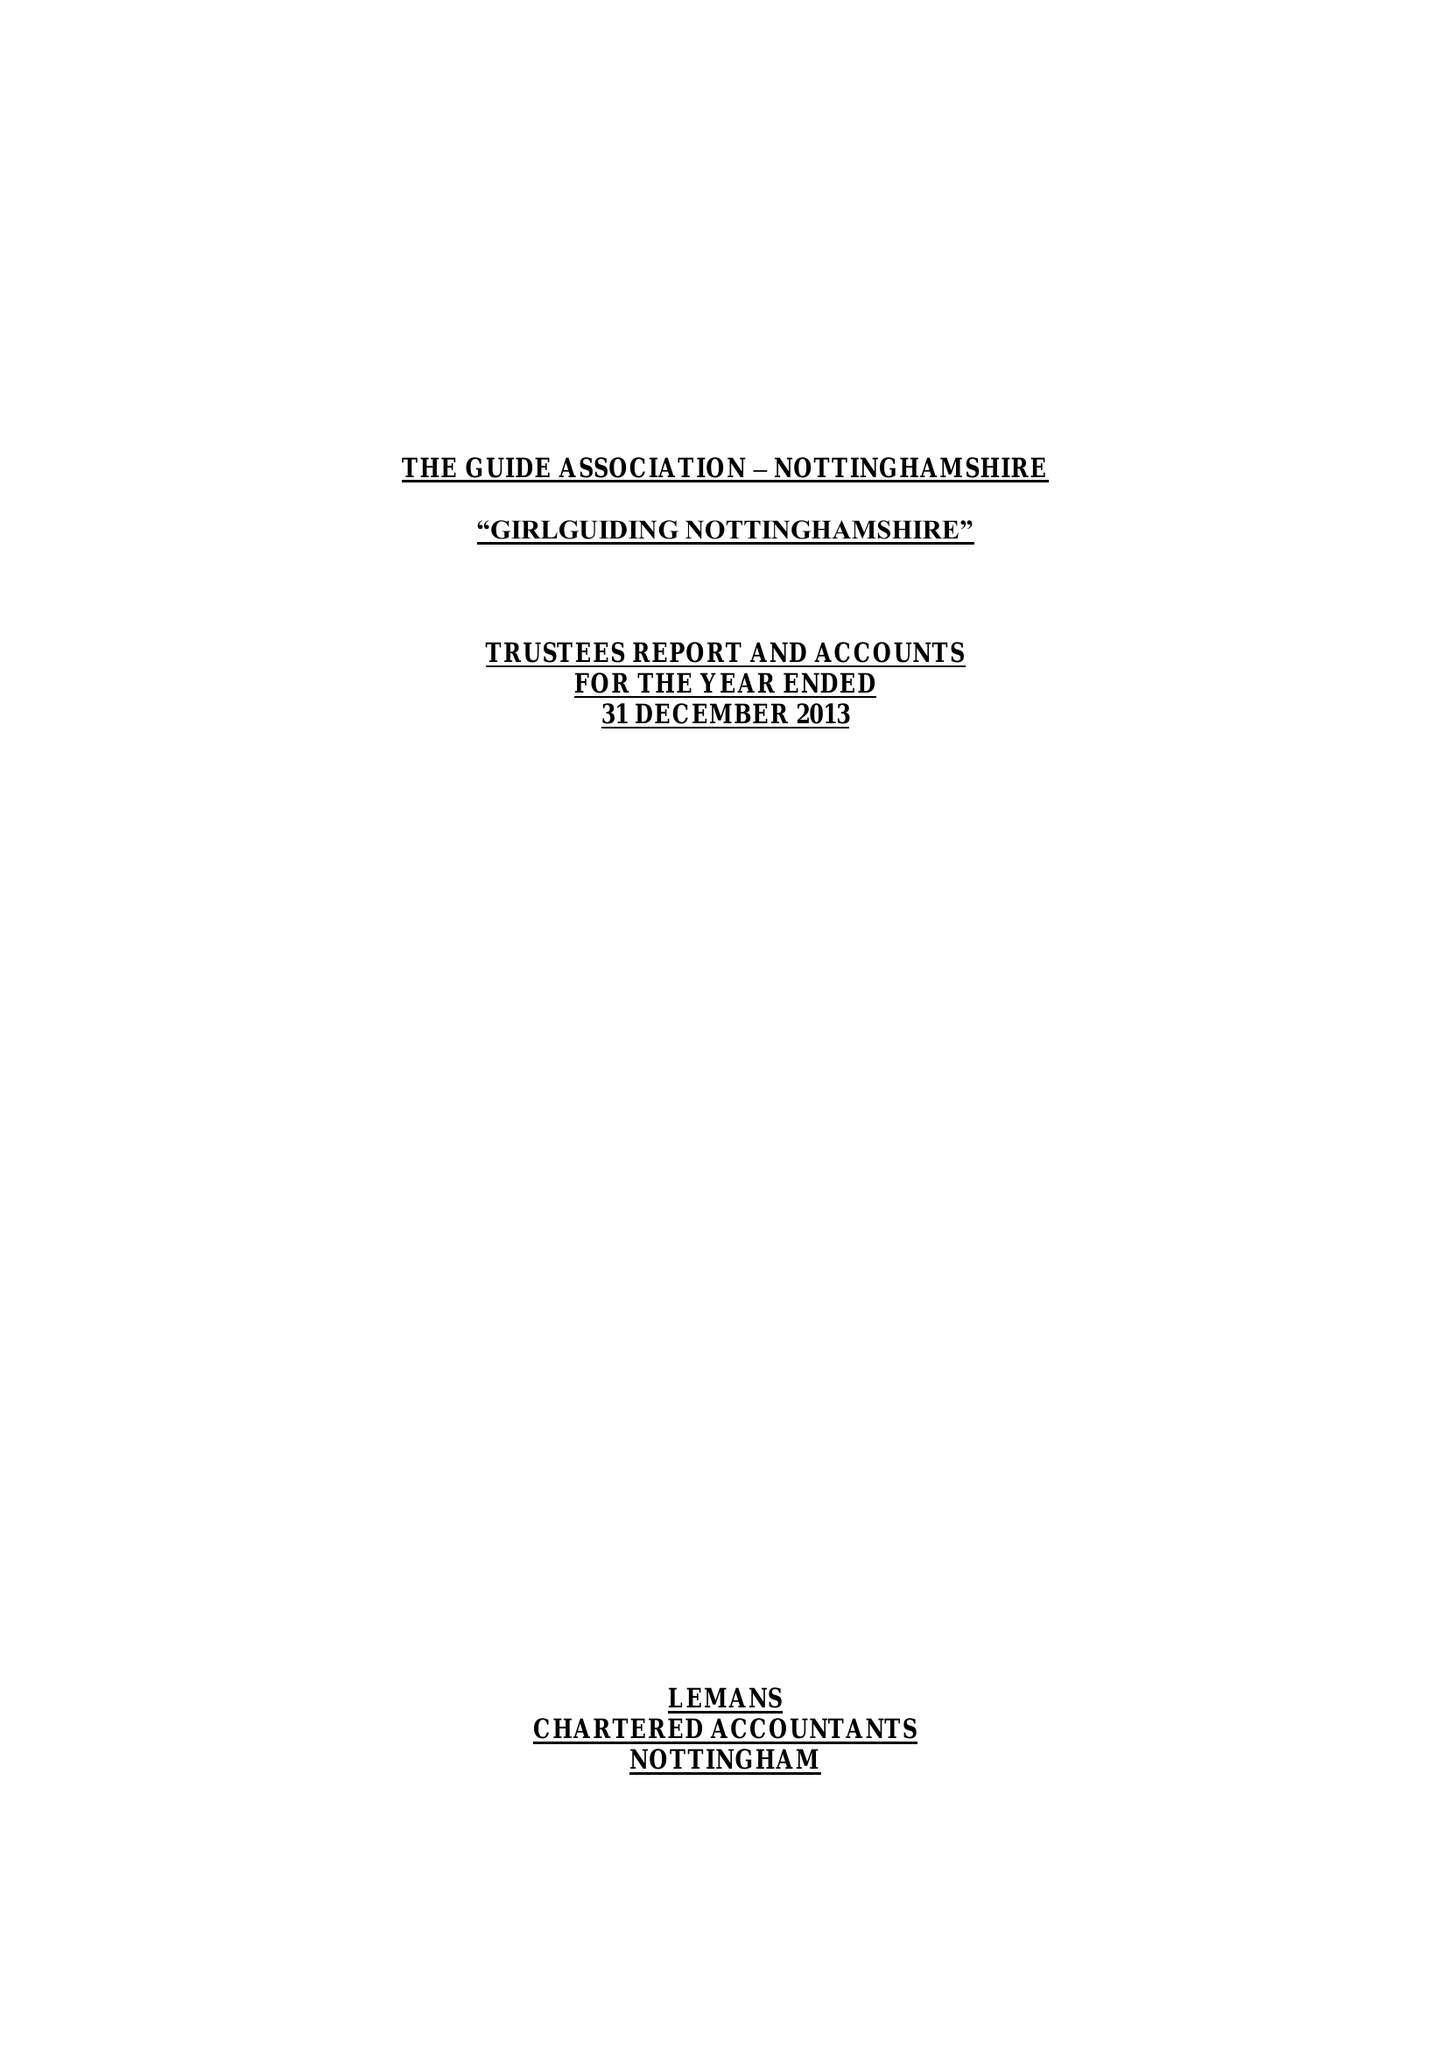What is the value for the income_annually_in_british_pounds?
Answer the question using a single word or phrase. 259933.00 